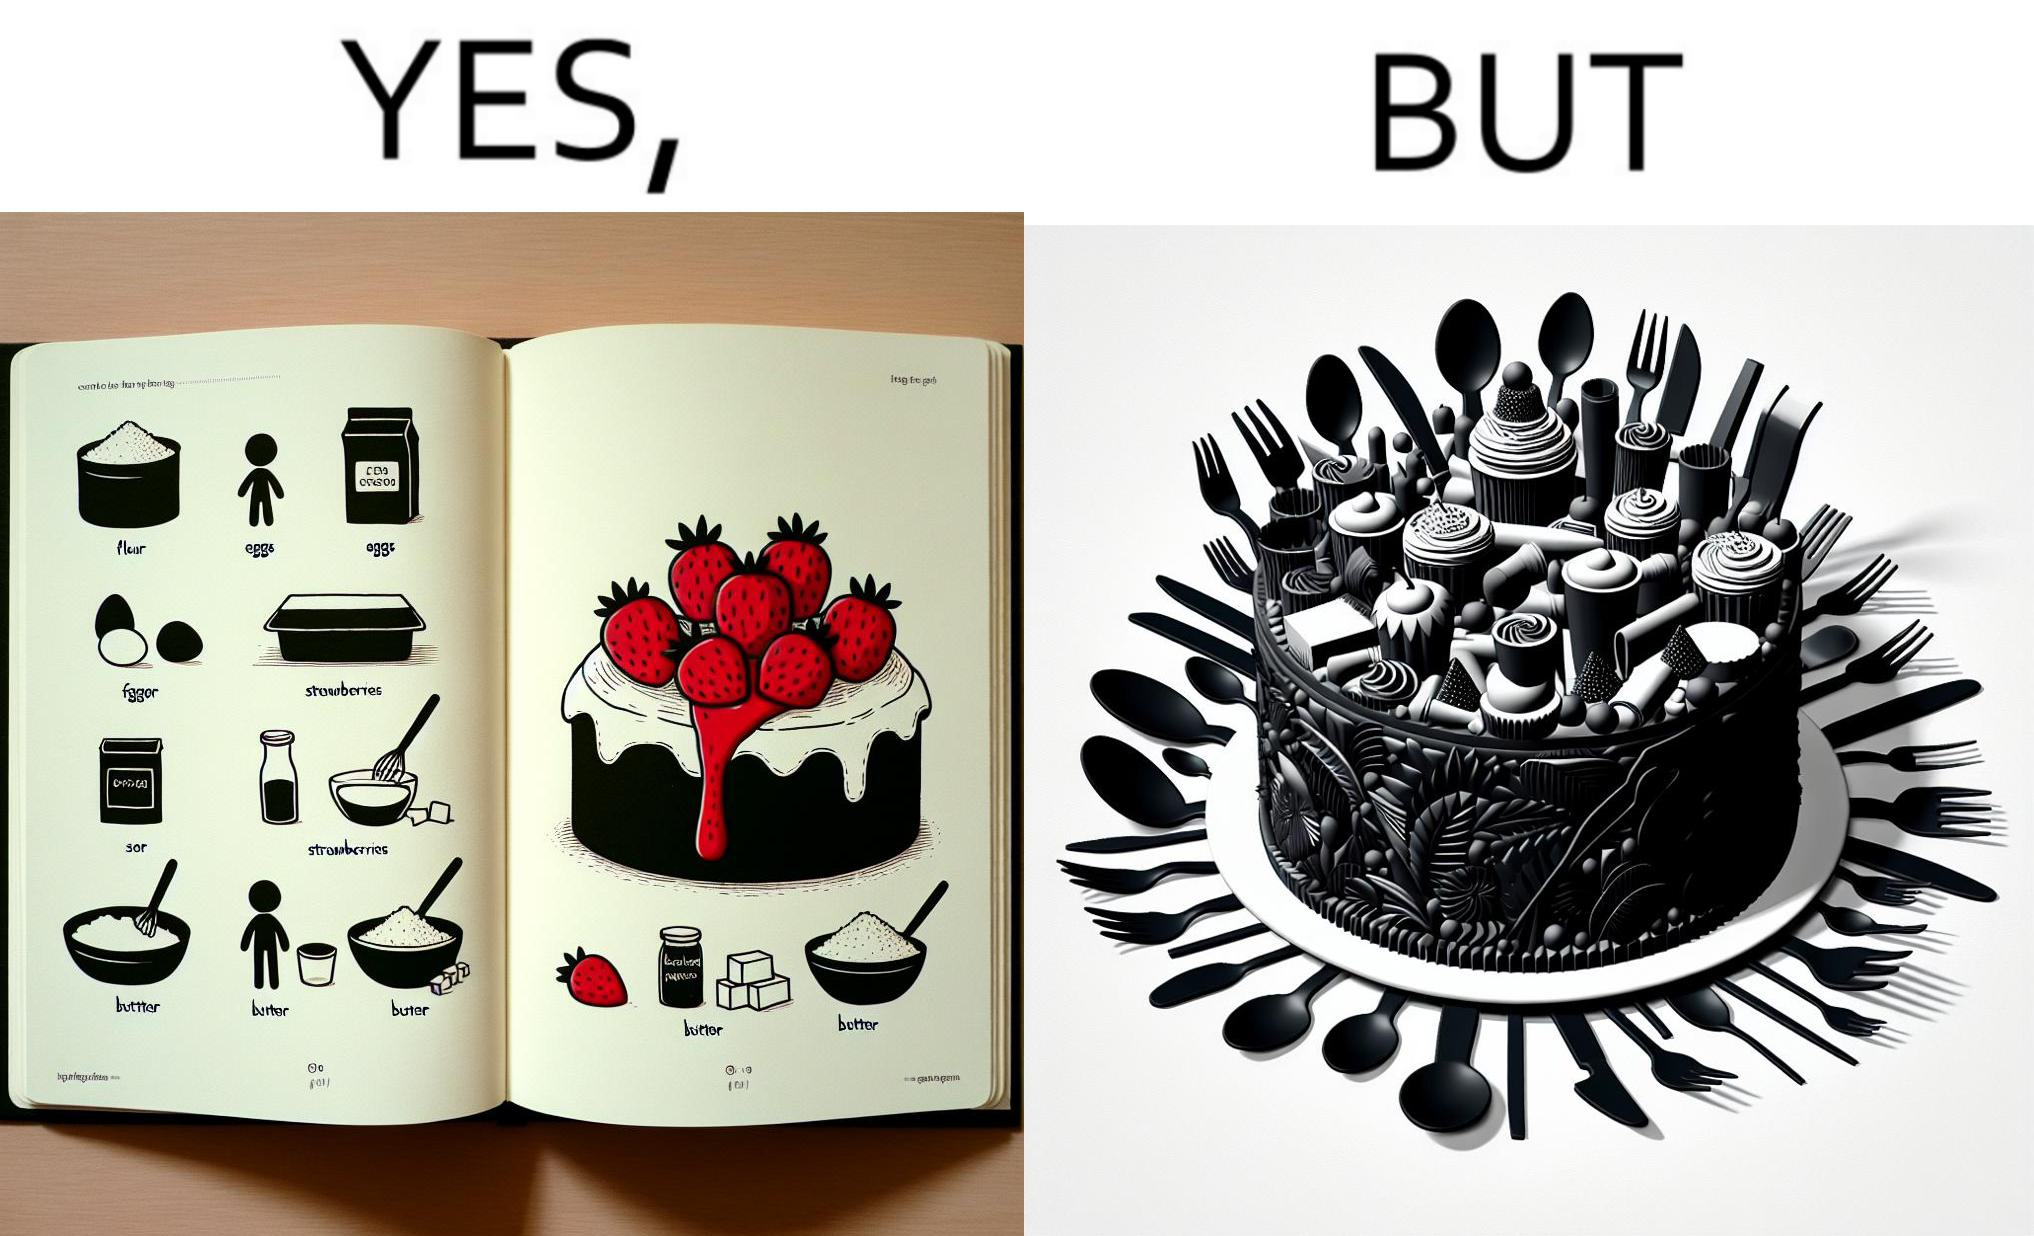Describe the contrast between the left and right parts of this image. In the left part of the image: a page of a book showing the image of a strawberry cake, along with its ingredients. In the right part of the image: a cake on a plate, along with a bunch of used utensils to be washed. 